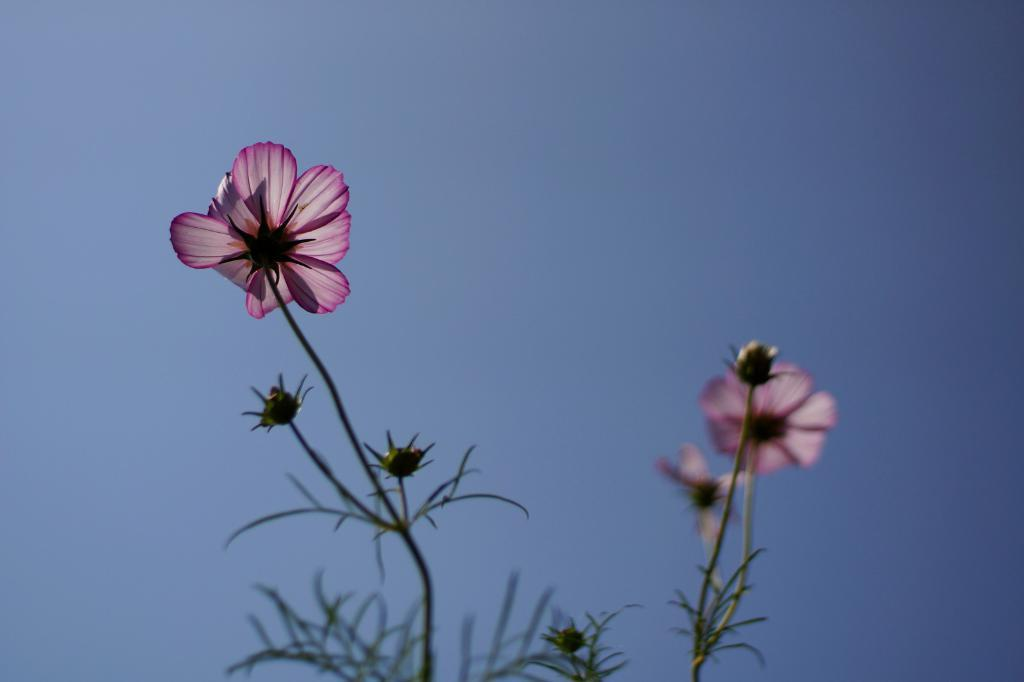What type of living organisms can be seen in the image? Plants can be seen in the image. What specific features can be observed on the plants? The plants have flowers and buds. What can be seen in the background of the image? There is a sky visible in the background of the image. What type of wrist accessory is visible on the plants in the image? There are no wrist accessories present in the image, as it features plants with flowers and buds. 